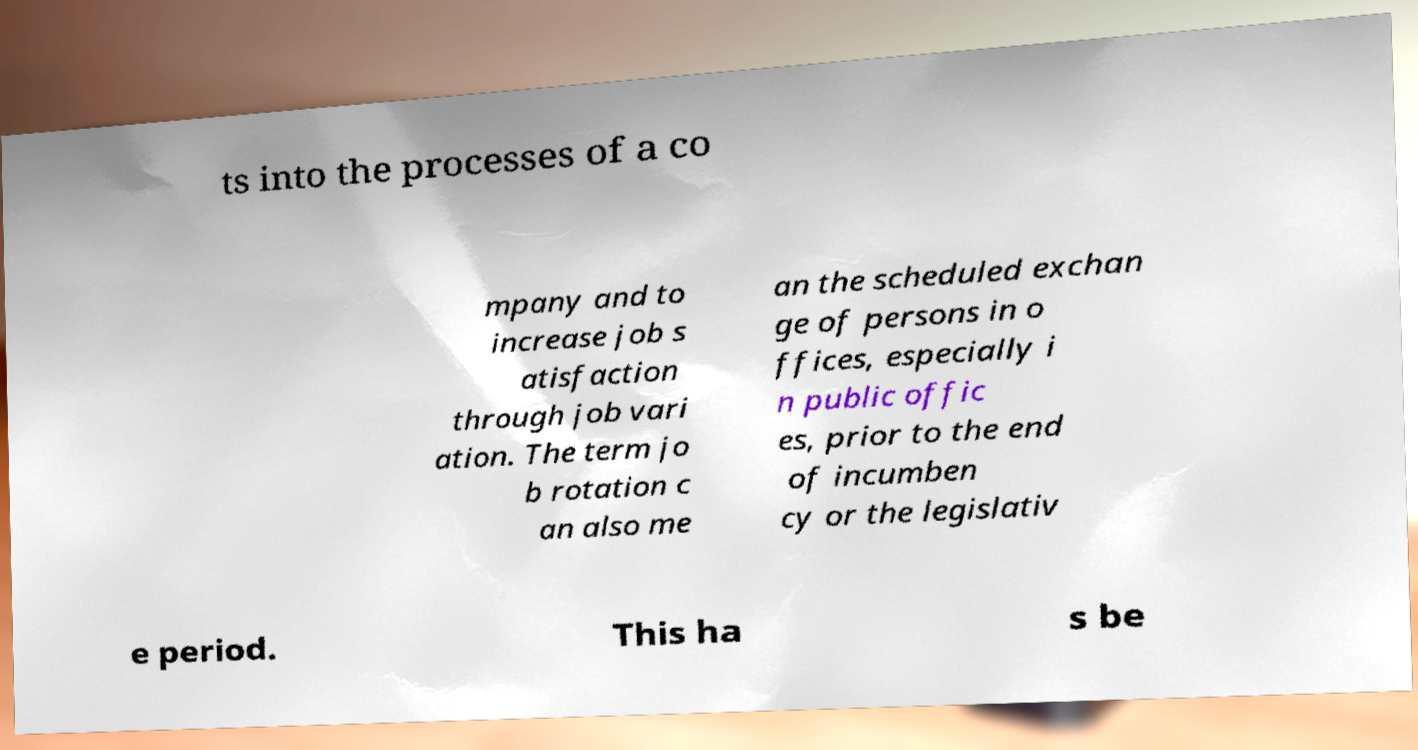Could you assist in decoding the text presented in this image and type it out clearly? ts into the processes of a co mpany and to increase job s atisfaction through job vari ation. The term jo b rotation c an also me an the scheduled exchan ge of persons in o ffices, especially i n public offic es, prior to the end of incumben cy or the legislativ e period. This ha s be 